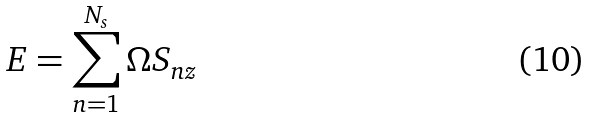<formula> <loc_0><loc_0><loc_500><loc_500>E = \sum _ { n = 1 } ^ { N _ { s } } \Omega S _ { n z }</formula> 